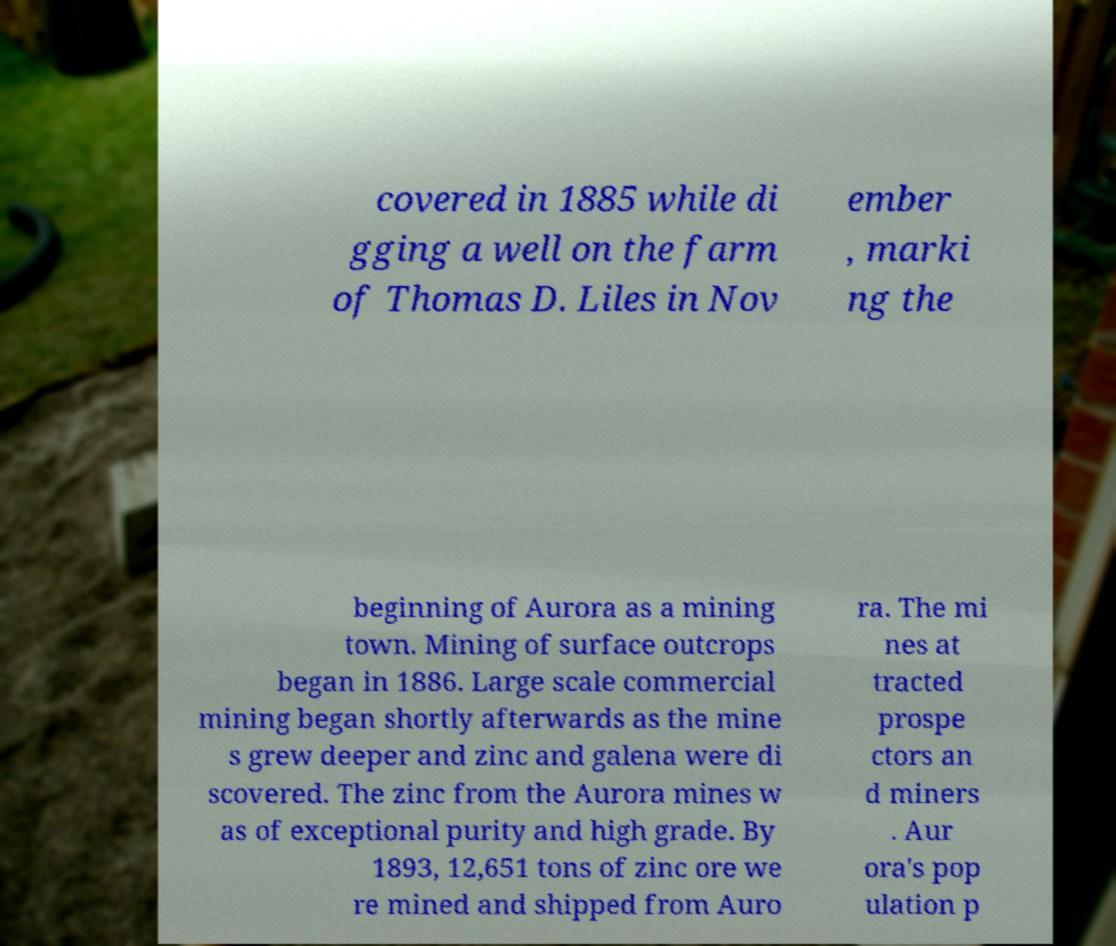Please identify and transcribe the text found in this image. covered in 1885 while di gging a well on the farm of Thomas D. Liles in Nov ember , marki ng the beginning of Aurora as a mining town. Mining of surface outcrops began in 1886. Large scale commercial mining began shortly afterwards as the mine s grew deeper and zinc and galena were di scovered. The zinc from the Aurora mines w as of exceptional purity and high grade. By 1893, 12,651 tons of zinc ore we re mined and shipped from Auro ra. The mi nes at tracted prospe ctors an d miners . Aur ora's pop ulation p 